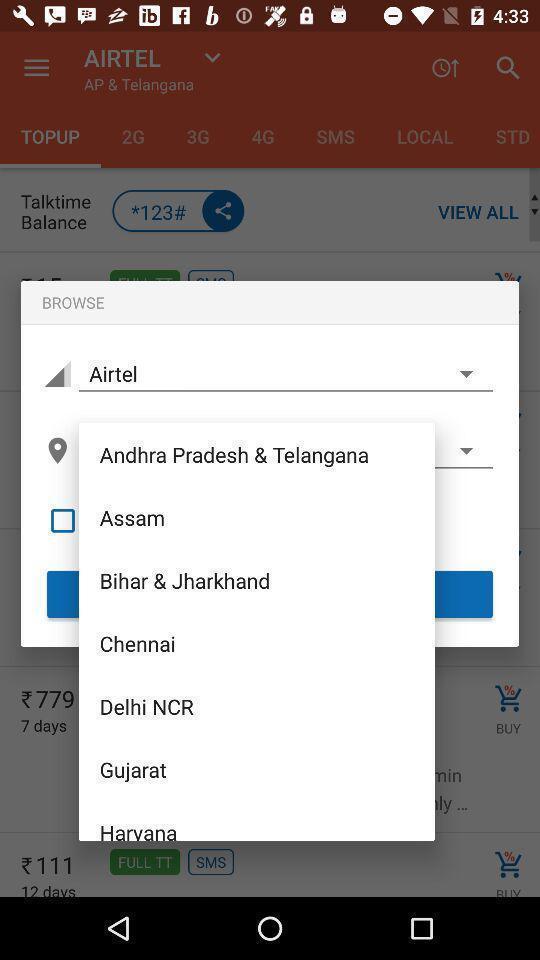Summarize the main components in this picture. Pop-up with different location recommendations. 